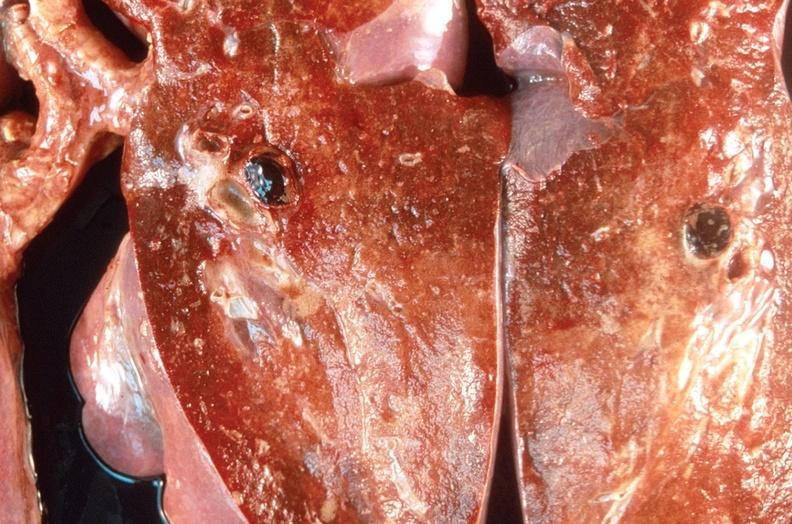s respiratory present?
Answer the question using a single word or phrase. Yes 